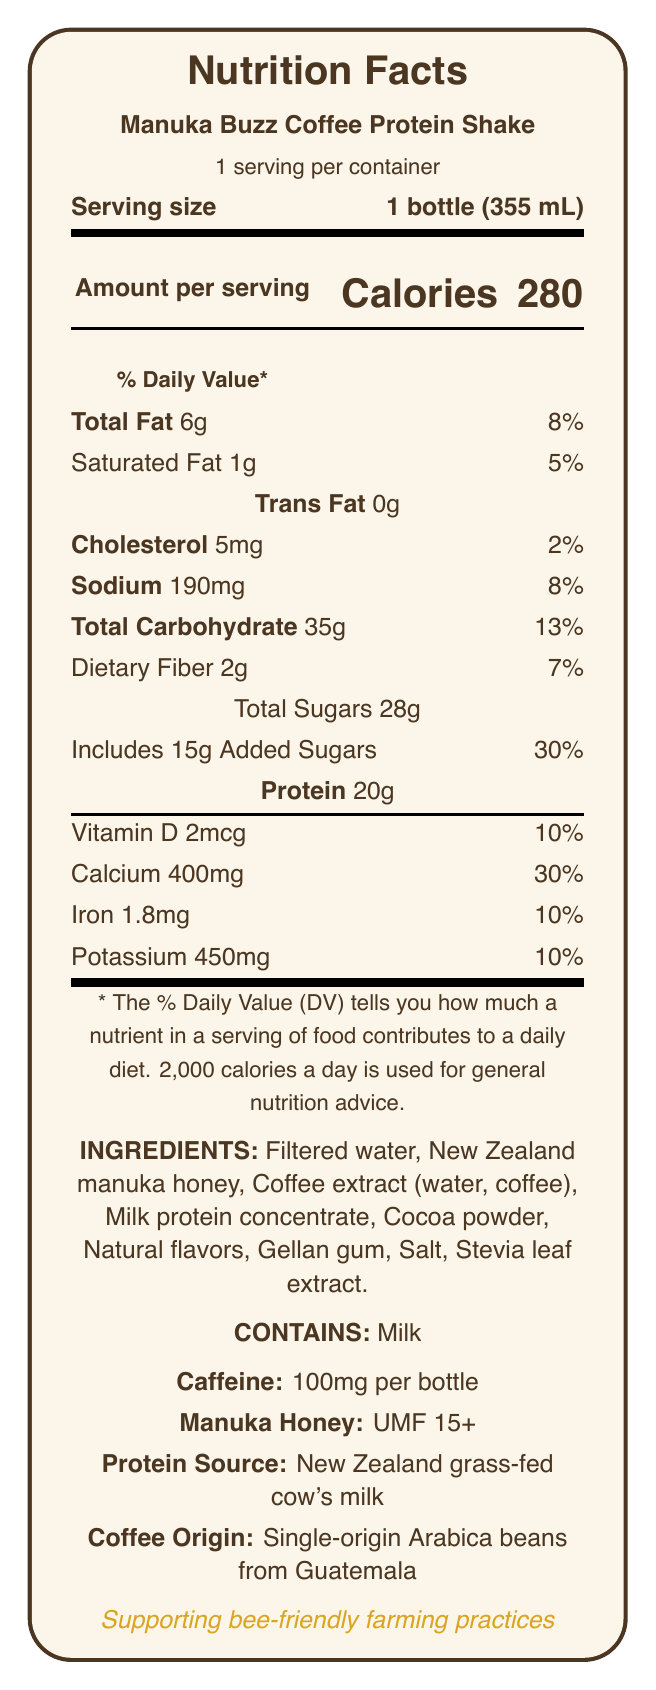What is the serving size of the Manuka Buzz Coffee Protein Shake? The serving size is clearly stated in the document under the "Serving size" section as "1 bottle (355 mL)".
Answer: 1 bottle (355 mL) How many calories are in one serving of the Manuka Buzz Coffee Protein Shake? The document lists "Calories" along with the number 280 under the "Amount per serving" section.
Answer: 280 What type of fat content is listed on the label? The document mentions "Total Fat", "Saturated Fat", and "Trans Fat" under the fat content section.
Answer: Total Fat, Saturated Fat, Trans Fat How much protein is in the Manuka Buzz Coffee Protein Shake? The document specifies 20g of protein under the "Protein" section.
Answer: 20g What are the flavor notes of the shake? The document lists "Rich coffee", "Creamy chocolate", and "Subtle floral honey" as the flavor notes under the "flavor_profile" section.
Answer: Rich coffee, Creamy chocolate, Subtle floral honey What is the caffeine content per bottle? A) 50mg B) 100mg C) 150mg D) 200mg The document lists the caffeine content as 100mg per bottle under the "additional_info" section.
Answer: B) 100mg What percentage of the daily value of calcium does one serving provide? A) 10% B) 20% C) 30% D) 40% Under the "Calcium" section, the document states that it provides 30% of the daily value.
Answer: C) 30% Is the coffee protein shake suitable for people who are lactose intolerant? The document explicitly states "Contains milk" under the allergens section, indicating it may not be suitable for those lactose intolerant.
Answer: No Summarize the main features of the Manuka Buzz Coffee Protein Shake. The document provides information about the ingredients, nutritional content, flavor profile, health benefits, and additional details like the source of ingredients and sustainability practices.
Answer: The Manuka Buzz Coffee Protein Shake is a high-protein beverage incorporating manuka honey from New Zealand, single-origin Arabica beans from Guatemala, and grass-fed cow's milk. It has 280 calories per bottle, with a rich blend of coffee and chocolate flavors, and offers nutritional benefits including protein for muscle recovery and antioxidants. How much of the shake's total carbohydrate content comes from dietary fiber? The dietary fiber content is listed as 2g under the "Total Carbohydrate" section.
Answer: 2g What is the rating of the Manuka honey used in the shake? The document mentions the Manuka honey rating as UMF 15+ under the "additional_info" section.
Answer: UMF 15+ Where is the coffee in the protein shake sourced from? The document states that the coffee origin is "Single-origin Arabica beans from Guatemala" under the "additional_info" section.
Answer: Single-origin Arabica beans from Guatemala What percentage of the daily value of iron is provided by one serving? The document lists that one serving provides 10% of the daily value of iron under the "Iron" section.
Answer: 10% Does the document mention the shelf stability if not refrigerated? The document only provides storage instructions stating, "Keep refrigerated. Consume within 3 days after opening," but does not mention shelf stability without refrigeration.
Answer: Cannot be determined 